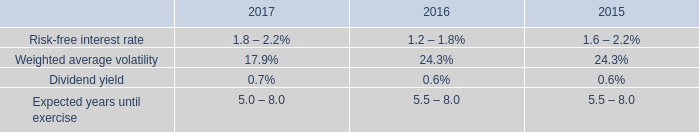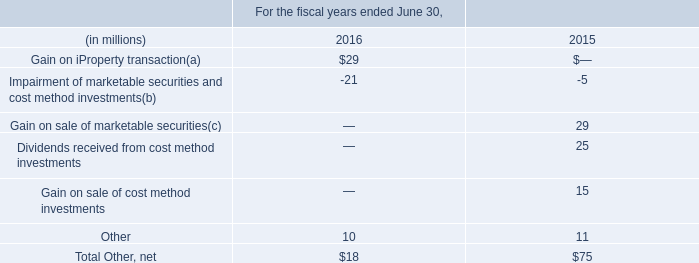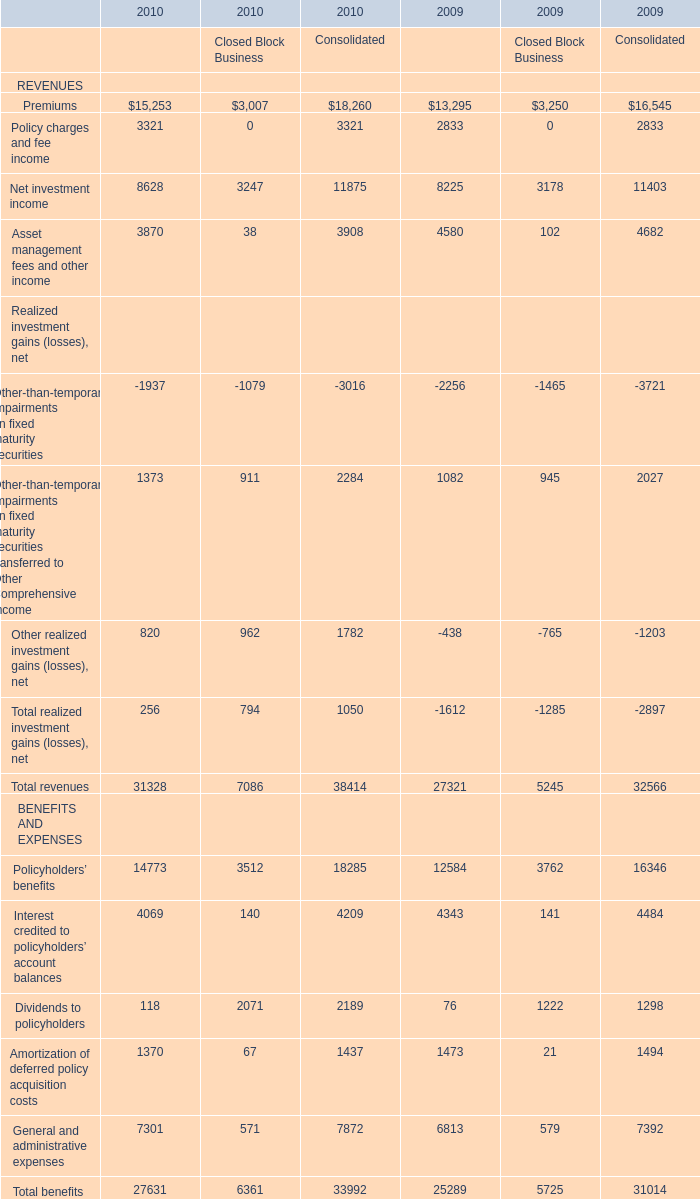What's the current growth rate of Policyholders’ benefits for Consolidate? 
Computations: ((18285 - 16346) / 16346)
Answer: 0.11862. 